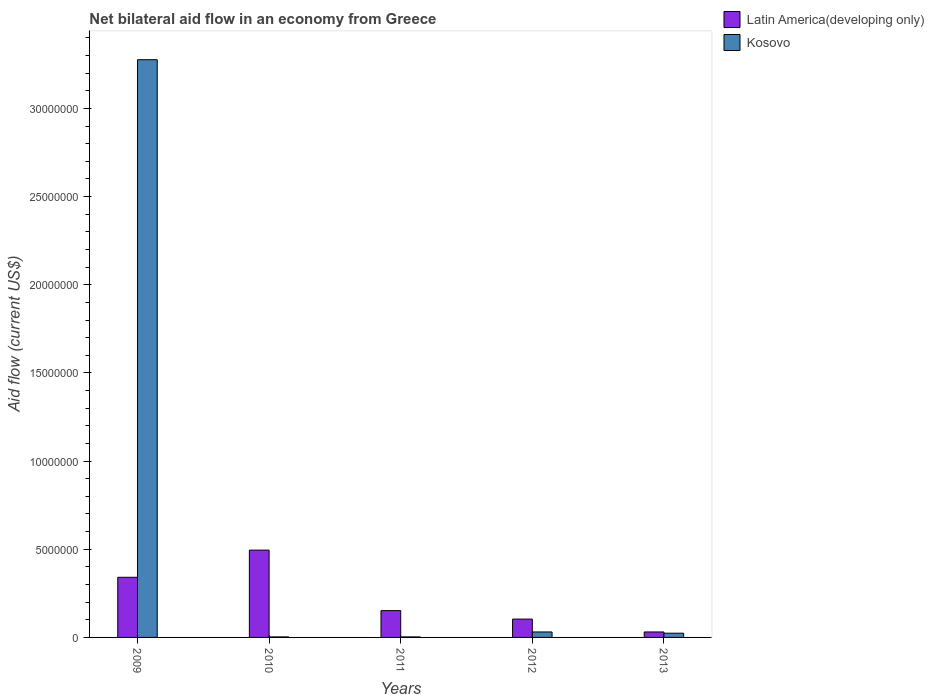How many groups of bars are there?
Offer a very short reply. 5. Are the number of bars per tick equal to the number of legend labels?
Offer a terse response. Yes. Are the number of bars on each tick of the X-axis equal?
Keep it short and to the point. Yes. How many bars are there on the 5th tick from the right?
Offer a very short reply. 2. What is the label of the 4th group of bars from the left?
Your response must be concise. 2012. In how many cases, is the number of bars for a given year not equal to the number of legend labels?
Your response must be concise. 0. What is the net bilateral aid flow in Latin America(developing only) in 2011?
Your response must be concise. 1.52e+06. Across all years, what is the maximum net bilateral aid flow in Latin America(developing only)?
Your answer should be very brief. 4.95e+06. Across all years, what is the minimum net bilateral aid flow in Kosovo?
Give a very brief answer. 3.00e+04. What is the total net bilateral aid flow in Latin America(developing only) in the graph?
Keep it short and to the point. 1.12e+07. What is the difference between the net bilateral aid flow in Latin America(developing only) in 2009 and that in 2012?
Offer a terse response. 2.37e+06. What is the difference between the net bilateral aid flow in Kosovo in 2009 and the net bilateral aid flow in Latin America(developing only) in 2013?
Your answer should be compact. 3.24e+07. What is the average net bilateral aid flow in Kosovo per year?
Provide a succinct answer. 6.67e+06. In the year 2009, what is the difference between the net bilateral aid flow in Kosovo and net bilateral aid flow in Latin America(developing only)?
Offer a very short reply. 2.94e+07. In how many years, is the net bilateral aid flow in Latin America(developing only) greater than 12000000 US$?
Your answer should be very brief. 0. What is the ratio of the net bilateral aid flow in Latin America(developing only) in 2010 to that in 2011?
Ensure brevity in your answer.  3.26. What is the difference between the highest and the second highest net bilateral aid flow in Kosovo?
Your answer should be very brief. 3.24e+07. What is the difference between the highest and the lowest net bilateral aid flow in Kosovo?
Provide a succinct answer. 3.27e+07. Is the sum of the net bilateral aid flow in Latin America(developing only) in 2012 and 2013 greater than the maximum net bilateral aid flow in Kosovo across all years?
Make the answer very short. No. What does the 2nd bar from the left in 2011 represents?
Offer a very short reply. Kosovo. What does the 2nd bar from the right in 2011 represents?
Keep it short and to the point. Latin America(developing only). Does the graph contain any zero values?
Give a very brief answer. No. Does the graph contain grids?
Offer a terse response. No. How are the legend labels stacked?
Your response must be concise. Vertical. What is the title of the graph?
Provide a succinct answer. Net bilateral aid flow in an economy from Greece. Does "Grenada" appear as one of the legend labels in the graph?
Provide a succinct answer. No. What is the label or title of the X-axis?
Keep it short and to the point. Years. What is the Aid flow (current US$) of Latin America(developing only) in 2009?
Your response must be concise. 3.41e+06. What is the Aid flow (current US$) in Kosovo in 2009?
Keep it short and to the point. 3.28e+07. What is the Aid flow (current US$) in Latin America(developing only) in 2010?
Your response must be concise. 4.95e+06. What is the Aid flow (current US$) in Latin America(developing only) in 2011?
Your response must be concise. 1.52e+06. What is the Aid flow (current US$) in Kosovo in 2011?
Keep it short and to the point. 3.00e+04. What is the Aid flow (current US$) of Latin America(developing only) in 2012?
Offer a terse response. 1.04e+06. What is the Aid flow (current US$) of Kosovo in 2012?
Keep it short and to the point. 3.10e+05. Across all years, what is the maximum Aid flow (current US$) of Latin America(developing only)?
Ensure brevity in your answer.  4.95e+06. Across all years, what is the maximum Aid flow (current US$) of Kosovo?
Offer a terse response. 3.28e+07. What is the total Aid flow (current US$) in Latin America(developing only) in the graph?
Your answer should be compact. 1.12e+07. What is the total Aid flow (current US$) of Kosovo in the graph?
Offer a very short reply. 3.34e+07. What is the difference between the Aid flow (current US$) in Latin America(developing only) in 2009 and that in 2010?
Offer a terse response. -1.54e+06. What is the difference between the Aid flow (current US$) in Kosovo in 2009 and that in 2010?
Give a very brief answer. 3.27e+07. What is the difference between the Aid flow (current US$) in Latin America(developing only) in 2009 and that in 2011?
Offer a very short reply. 1.89e+06. What is the difference between the Aid flow (current US$) of Kosovo in 2009 and that in 2011?
Your response must be concise. 3.27e+07. What is the difference between the Aid flow (current US$) of Latin America(developing only) in 2009 and that in 2012?
Your answer should be very brief. 2.37e+06. What is the difference between the Aid flow (current US$) in Kosovo in 2009 and that in 2012?
Your answer should be compact. 3.24e+07. What is the difference between the Aid flow (current US$) of Latin America(developing only) in 2009 and that in 2013?
Provide a short and direct response. 3.10e+06. What is the difference between the Aid flow (current US$) in Kosovo in 2009 and that in 2013?
Ensure brevity in your answer.  3.25e+07. What is the difference between the Aid flow (current US$) of Latin America(developing only) in 2010 and that in 2011?
Give a very brief answer. 3.43e+06. What is the difference between the Aid flow (current US$) of Latin America(developing only) in 2010 and that in 2012?
Offer a very short reply. 3.91e+06. What is the difference between the Aid flow (current US$) of Kosovo in 2010 and that in 2012?
Provide a succinct answer. -2.80e+05. What is the difference between the Aid flow (current US$) in Latin America(developing only) in 2010 and that in 2013?
Provide a succinct answer. 4.64e+06. What is the difference between the Aid flow (current US$) of Kosovo in 2010 and that in 2013?
Keep it short and to the point. -2.10e+05. What is the difference between the Aid flow (current US$) of Kosovo in 2011 and that in 2012?
Provide a succinct answer. -2.80e+05. What is the difference between the Aid flow (current US$) in Latin America(developing only) in 2011 and that in 2013?
Make the answer very short. 1.21e+06. What is the difference between the Aid flow (current US$) of Latin America(developing only) in 2012 and that in 2013?
Offer a terse response. 7.30e+05. What is the difference between the Aid flow (current US$) in Latin America(developing only) in 2009 and the Aid flow (current US$) in Kosovo in 2010?
Your response must be concise. 3.38e+06. What is the difference between the Aid flow (current US$) in Latin America(developing only) in 2009 and the Aid flow (current US$) in Kosovo in 2011?
Ensure brevity in your answer.  3.38e+06. What is the difference between the Aid flow (current US$) in Latin America(developing only) in 2009 and the Aid flow (current US$) in Kosovo in 2012?
Offer a terse response. 3.10e+06. What is the difference between the Aid flow (current US$) in Latin America(developing only) in 2009 and the Aid flow (current US$) in Kosovo in 2013?
Provide a succinct answer. 3.17e+06. What is the difference between the Aid flow (current US$) of Latin America(developing only) in 2010 and the Aid flow (current US$) of Kosovo in 2011?
Offer a very short reply. 4.92e+06. What is the difference between the Aid flow (current US$) of Latin America(developing only) in 2010 and the Aid flow (current US$) of Kosovo in 2012?
Your answer should be compact. 4.64e+06. What is the difference between the Aid flow (current US$) of Latin America(developing only) in 2010 and the Aid flow (current US$) of Kosovo in 2013?
Ensure brevity in your answer.  4.71e+06. What is the difference between the Aid flow (current US$) in Latin America(developing only) in 2011 and the Aid flow (current US$) in Kosovo in 2012?
Make the answer very short. 1.21e+06. What is the difference between the Aid flow (current US$) of Latin America(developing only) in 2011 and the Aid flow (current US$) of Kosovo in 2013?
Give a very brief answer. 1.28e+06. What is the difference between the Aid flow (current US$) in Latin America(developing only) in 2012 and the Aid flow (current US$) in Kosovo in 2013?
Offer a very short reply. 8.00e+05. What is the average Aid flow (current US$) in Latin America(developing only) per year?
Keep it short and to the point. 2.25e+06. What is the average Aid flow (current US$) of Kosovo per year?
Your response must be concise. 6.67e+06. In the year 2009, what is the difference between the Aid flow (current US$) of Latin America(developing only) and Aid flow (current US$) of Kosovo?
Keep it short and to the point. -2.94e+07. In the year 2010, what is the difference between the Aid flow (current US$) of Latin America(developing only) and Aid flow (current US$) of Kosovo?
Your answer should be compact. 4.92e+06. In the year 2011, what is the difference between the Aid flow (current US$) of Latin America(developing only) and Aid flow (current US$) of Kosovo?
Offer a terse response. 1.49e+06. In the year 2012, what is the difference between the Aid flow (current US$) of Latin America(developing only) and Aid flow (current US$) of Kosovo?
Offer a terse response. 7.30e+05. What is the ratio of the Aid flow (current US$) of Latin America(developing only) in 2009 to that in 2010?
Your answer should be very brief. 0.69. What is the ratio of the Aid flow (current US$) in Kosovo in 2009 to that in 2010?
Provide a short and direct response. 1092. What is the ratio of the Aid flow (current US$) in Latin America(developing only) in 2009 to that in 2011?
Offer a very short reply. 2.24. What is the ratio of the Aid flow (current US$) in Kosovo in 2009 to that in 2011?
Your response must be concise. 1092. What is the ratio of the Aid flow (current US$) in Latin America(developing only) in 2009 to that in 2012?
Your answer should be very brief. 3.28. What is the ratio of the Aid flow (current US$) of Kosovo in 2009 to that in 2012?
Make the answer very short. 105.68. What is the ratio of the Aid flow (current US$) of Latin America(developing only) in 2009 to that in 2013?
Offer a terse response. 11. What is the ratio of the Aid flow (current US$) of Kosovo in 2009 to that in 2013?
Your response must be concise. 136.5. What is the ratio of the Aid flow (current US$) in Latin America(developing only) in 2010 to that in 2011?
Your response must be concise. 3.26. What is the ratio of the Aid flow (current US$) in Latin America(developing only) in 2010 to that in 2012?
Make the answer very short. 4.76. What is the ratio of the Aid flow (current US$) in Kosovo in 2010 to that in 2012?
Your answer should be compact. 0.1. What is the ratio of the Aid flow (current US$) of Latin America(developing only) in 2010 to that in 2013?
Give a very brief answer. 15.97. What is the ratio of the Aid flow (current US$) in Kosovo in 2010 to that in 2013?
Offer a very short reply. 0.12. What is the ratio of the Aid flow (current US$) in Latin America(developing only) in 2011 to that in 2012?
Offer a very short reply. 1.46. What is the ratio of the Aid flow (current US$) in Kosovo in 2011 to that in 2012?
Offer a terse response. 0.1. What is the ratio of the Aid flow (current US$) of Latin America(developing only) in 2011 to that in 2013?
Make the answer very short. 4.9. What is the ratio of the Aid flow (current US$) of Latin America(developing only) in 2012 to that in 2013?
Your answer should be very brief. 3.35. What is the ratio of the Aid flow (current US$) in Kosovo in 2012 to that in 2013?
Ensure brevity in your answer.  1.29. What is the difference between the highest and the second highest Aid flow (current US$) of Latin America(developing only)?
Your answer should be very brief. 1.54e+06. What is the difference between the highest and the second highest Aid flow (current US$) of Kosovo?
Ensure brevity in your answer.  3.24e+07. What is the difference between the highest and the lowest Aid flow (current US$) in Latin America(developing only)?
Your answer should be very brief. 4.64e+06. What is the difference between the highest and the lowest Aid flow (current US$) in Kosovo?
Make the answer very short. 3.27e+07. 